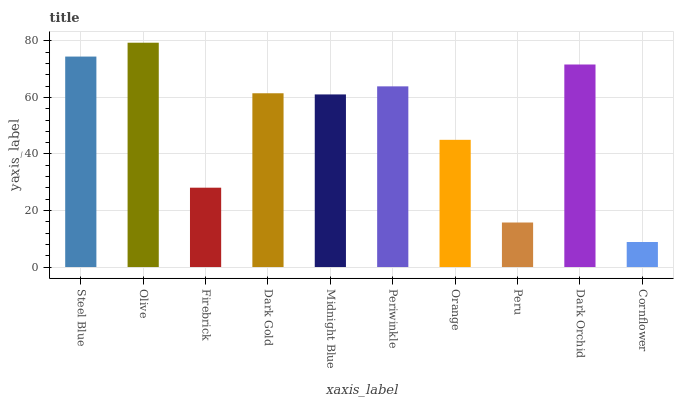Is Cornflower the minimum?
Answer yes or no. Yes. Is Olive the maximum?
Answer yes or no. Yes. Is Firebrick the minimum?
Answer yes or no. No. Is Firebrick the maximum?
Answer yes or no. No. Is Olive greater than Firebrick?
Answer yes or no. Yes. Is Firebrick less than Olive?
Answer yes or no. Yes. Is Firebrick greater than Olive?
Answer yes or no. No. Is Olive less than Firebrick?
Answer yes or no. No. Is Dark Gold the high median?
Answer yes or no. Yes. Is Midnight Blue the low median?
Answer yes or no. Yes. Is Dark Orchid the high median?
Answer yes or no. No. Is Dark Orchid the low median?
Answer yes or no. No. 